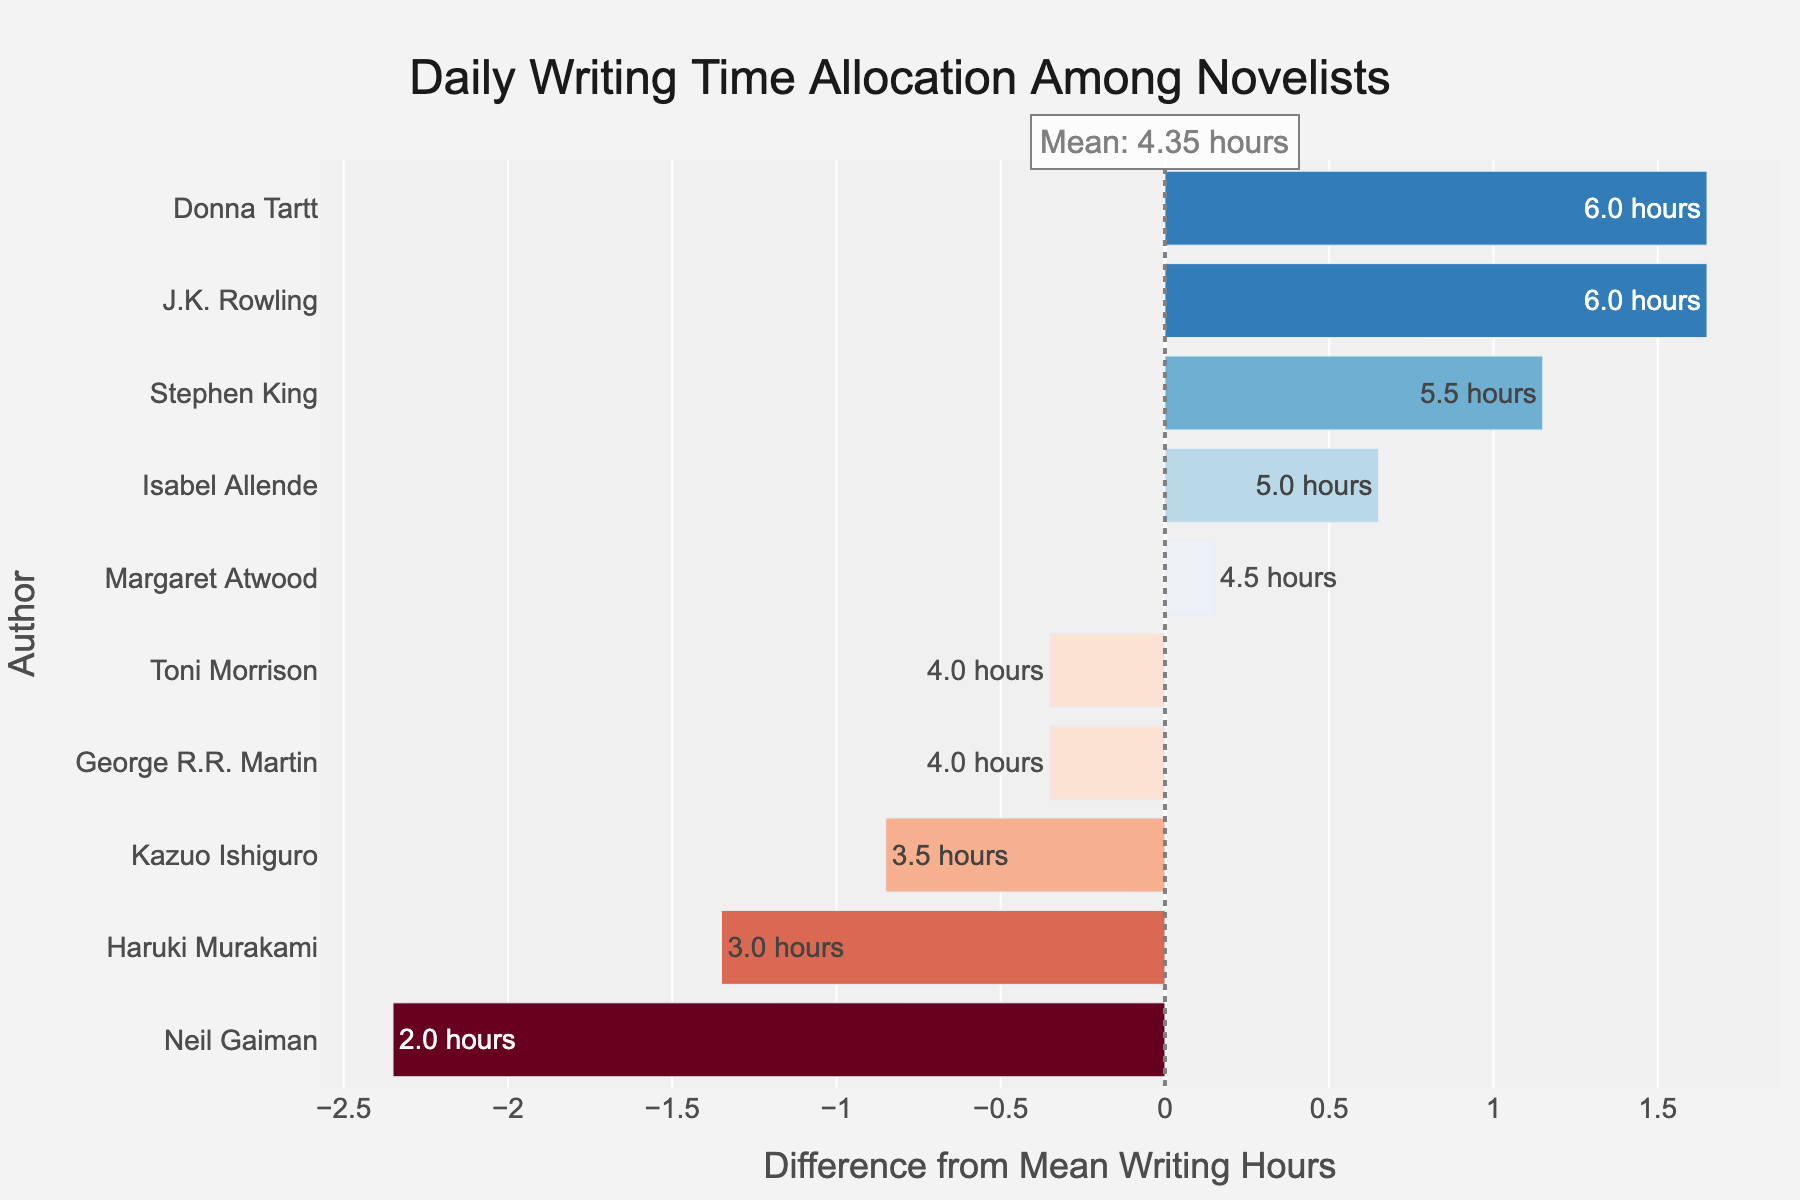what is the mean daily writing hours among novelists? The mean daily writing hours is calculated using the mean of the Daily_Writing_Hours column in the provided data. The mean is given in the annotation in the figure.
Answer: 4.45 hours which novelist spends the most amount of daily writing time? By examining the length of the bars on the right-hand side of the vertical line, we can observe the bar with the largest positive difference from the mean. This corresponds to J.K. Rowling.
Answer: J.K. Rowling what is the daily writing time of Donna Tartt and how much more is it compared to George R.R. Martin? Donna Tartt writes for 6 hours daily, whereas George R.R. Martin writes for 4 hours. The difference is 6 - 4 = 2 hours.
Answer: 2 hours how many novelists write more than the mean daily writing hours? Novelists with positive differences from the mean daily writing hours are indicated by bars extending to the right of the vertical line. By counting these bars, we find the total number of such novelists.
Answer: 5 do any two novelists have the same satisfaction level, and if so, who are they? By examining the Satisfaction_Level column in the data, we can see if there are any pairs of novelists with identical satisfaction levels. Both Neil Gaiman and George R.R. Martin have a satisfaction level of 6.
Answer: Neil Gaiman and George R.R. Martin what is the total difference in daily writing hours between Stephen King and Kazuo Ishiguro from the mean? Stephen King's and Kazuo Ishiguro's differences from the mean can be summed up. Stephen King has a difference of 1.05 hours and Kazuo Ishiguro has a difference of -0.95 hours, so the total difference is 1.05 + (-0.95) = 0.10 hours.
Answer: 0.10 hours which author is closest to writing the mean amount of daily hours? By observing the bars in the chart, the author whose bar's endpoint is nearest the vertical line representing the mean is identified. Kazuo Ishiguro's bar is closest to this line.
Answer: Kazuo Ishiguro how does Isabel Allende’s daily writing time compare to Haruki Murakami's? Isabel Allende writes for 5 hours daily, while Haruki Murakami writes for 3 hours. The difference between them is 5 - 3 = 2 hours, meaning Isabel Allende writes 2 hours more daily than Haruki Murakami.
Answer: Isabel Allende writes 2 hours more 